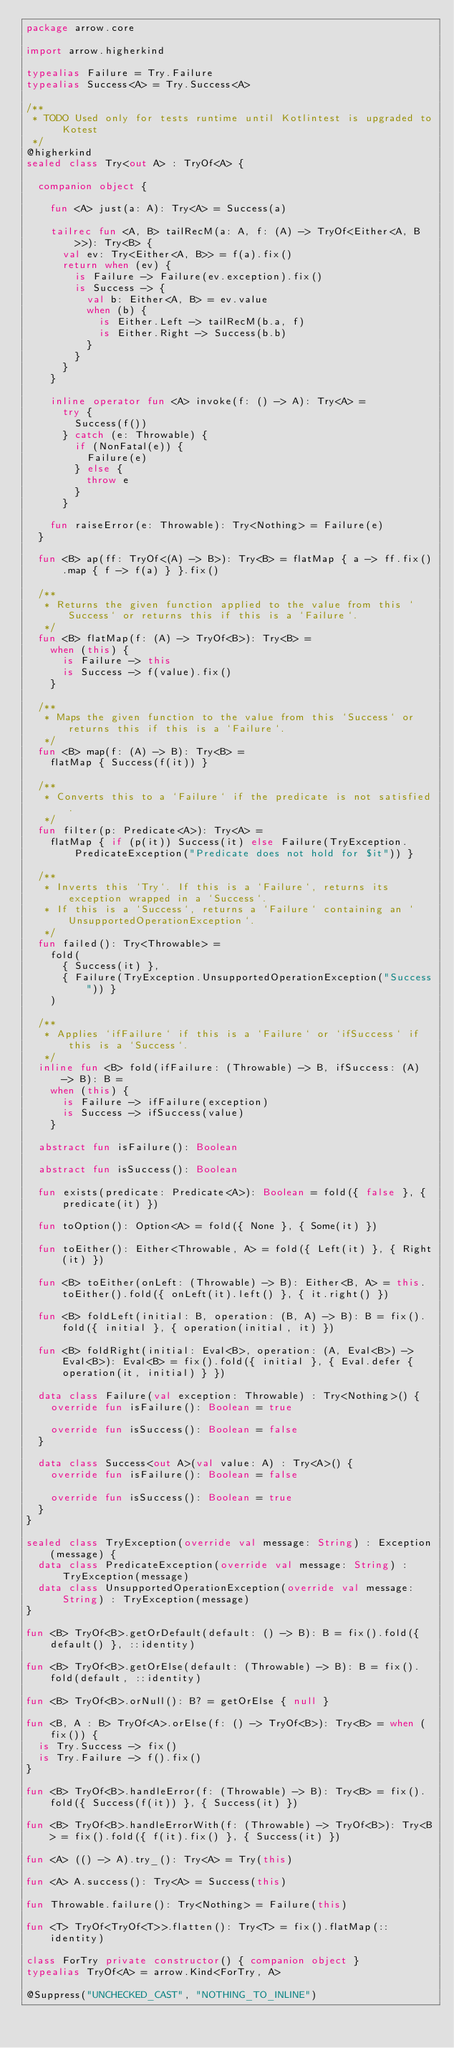<code> <loc_0><loc_0><loc_500><loc_500><_Kotlin_>package arrow.core

import arrow.higherkind

typealias Failure = Try.Failure
typealias Success<A> = Try.Success<A>

/**
 * TODO Used only for tests runtime until Kotlintest is upgraded to Kotest
 */
@higherkind
sealed class Try<out A> : TryOf<A> {

  companion object {

    fun <A> just(a: A): Try<A> = Success(a)

    tailrec fun <A, B> tailRecM(a: A, f: (A) -> TryOf<Either<A, B>>): Try<B> {
      val ev: Try<Either<A, B>> = f(a).fix()
      return when (ev) {
        is Failure -> Failure(ev.exception).fix()
        is Success -> {
          val b: Either<A, B> = ev.value
          when (b) {
            is Either.Left -> tailRecM(b.a, f)
            is Either.Right -> Success(b.b)
          }
        }
      }
    }

    inline operator fun <A> invoke(f: () -> A): Try<A> =
      try {
        Success(f())
      } catch (e: Throwable) {
        if (NonFatal(e)) {
          Failure(e)
        } else {
          throw e
        }
      }

    fun raiseError(e: Throwable): Try<Nothing> = Failure(e)
  }

  fun <B> ap(ff: TryOf<(A) -> B>): Try<B> = flatMap { a -> ff.fix().map { f -> f(a) } }.fix()

  /**
   * Returns the given function applied to the value from this `Success` or returns this if this is a `Failure`.
   */
  fun <B> flatMap(f: (A) -> TryOf<B>): Try<B> =
    when (this) {
      is Failure -> this
      is Success -> f(value).fix()
    }

  /**
   * Maps the given function to the value from this `Success` or returns this if this is a `Failure`.
   */
  fun <B> map(f: (A) -> B): Try<B> =
    flatMap { Success(f(it)) }

  /**
   * Converts this to a `Failure` if the predicate is not satisfied.
   */
  fun filter(p: Predicate<A>): Try<A> =
    flatMap { if (p(it)) Success(it) else Failure(TryException.PredicateException("Predicate does not hold for $it")) }

  /**
   * Inverts this `Try`. If this is a `Failure`, returns its exception wrapped in a `Success`.
   * If this is a `Success`, returns a `Failure` containing an `UnsupportedOperationException`.
   */
  fun failed(): Try<Throwable> =
    fold(
      { Success(it) },
      { Failure(TryException.UnsupportedOperationException("Success")) }
    )

  /**
   * Applies `ifFailure` if this is a `Failure` or `ifSuccess` if this is a `Success`.
   */
  inline fun <B> fold(ifFailure: (Throwable) -> B, ifSuccess: (A) -> B): B =
    when (this) {
      is Failure -> ifFailure(exception)
      is Success -> ifSuccess(value)
    }

  abstract fun isFailure(): Boolean

  abstract fun isSuccess(): Boolean

  fun exists(predicate: Predicate<A>): Boolean = fold({ false }, { predicate(it) })

  fun toOption(): Option<A> = fold({ None }, { Some(it) })

  fun toEither(): Either<Throwable, A> = fold({ Left(it) }, { Right(it) })

  fun <B> toEither(onLeft: (Throwable) -> B): Either<B, A> = this.toEither().fold({ onLeft(it).left() }, { it.right() })

  fun <B> foldLeft(initial: B, operation: (B, A) -> B): B = fix().fold({ initial }, { operation(initial, it) })

  fun <B> foldRight(initial: Eval<B>, operation: (A, Eval<B>) -> Eval<B>): Eval<B> = fix().fold({ initial }, { Eval.defer { operation(it, initial) } })

  data class Failure(val exception: Throwable) : Try<Nothing>() {
    override fun isFailure(): Boolean = true

    override fun isSuccess(): Boolean = false
  }

  data class Success<out A>(val value: A) : Try<A>() {
    override fun isFailure(): Boolean = false

    override fun isSuccess(): Boolean = true
  }
}

sealed class TryException(override val message: String) : Exception(message) {
  data class PredicateException(override val message: String) : TryException(message)
  data class UnsupportedOperationException(override val message: String) : TryException(message)
}

fun <B> TryOf<B>.getOrDefault(default: () -> B): B = fix().fold({ default() }, ::identity)

fun <B> TryOf<B>.getOrElse(default: (Throwable) -> B): B = fix().fold(default, ::identity)

fun <B> TryOf<B>.orNull(): B? = getOrElse { null }

fun <B, A : B> TryOf<A>.orElse(f: () -> TryOf<B>): Try<B> = when (fix()) {
  is Try.Success -> fix()
  is Try.Failure -> f().fix()
}

fun <B> TryOf<B>.handleError(f: (Throwable) -> B): Try<B> = fix().fold({ Success(f(it)) }, { Success(it) })

fun <B> TryOf<B>.handleErrorWith(f: (Throwable) -> TryOf<B>): Try<B> = fix().fold({ f(it).fix() }, { Success(it) })

fun <A> (() -> A).try_(): Try<A> = Try(this)

fun <A> A.success(): Try<A> = Success(this)

fun Throwable.failure(): Try<Nothing> = Failure(this)

fun <T> TryOf<TryOf<T>>.flatten(): Try<T> = fix().flatMap(::identity)

class ForTry private constructor() { companion object }
typealias TryOf<A> = arrow.Kind<ForTry, A>

@Suppress("UNCHECKED_CAST", "NOTHING_TO_INLINE")</code> 